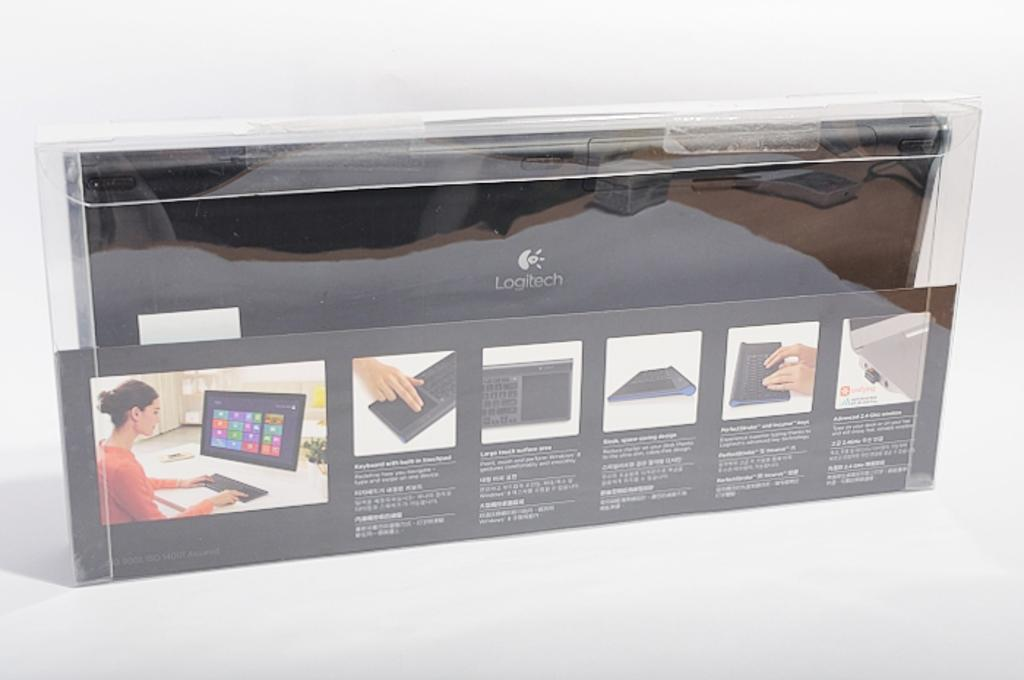What electronic device is visible in the image? There is a keyboard in the image. How is the keyboard being stored or transported? The keyboard is packed in a plastic box. Are there any additional materials or information provided in the image? Yes, there are instructions at the bottom of the image. What type of map can be seen in the image? There is no map present in the image; it features a keyboard packed in a plastic box and instructions at the bottom. 